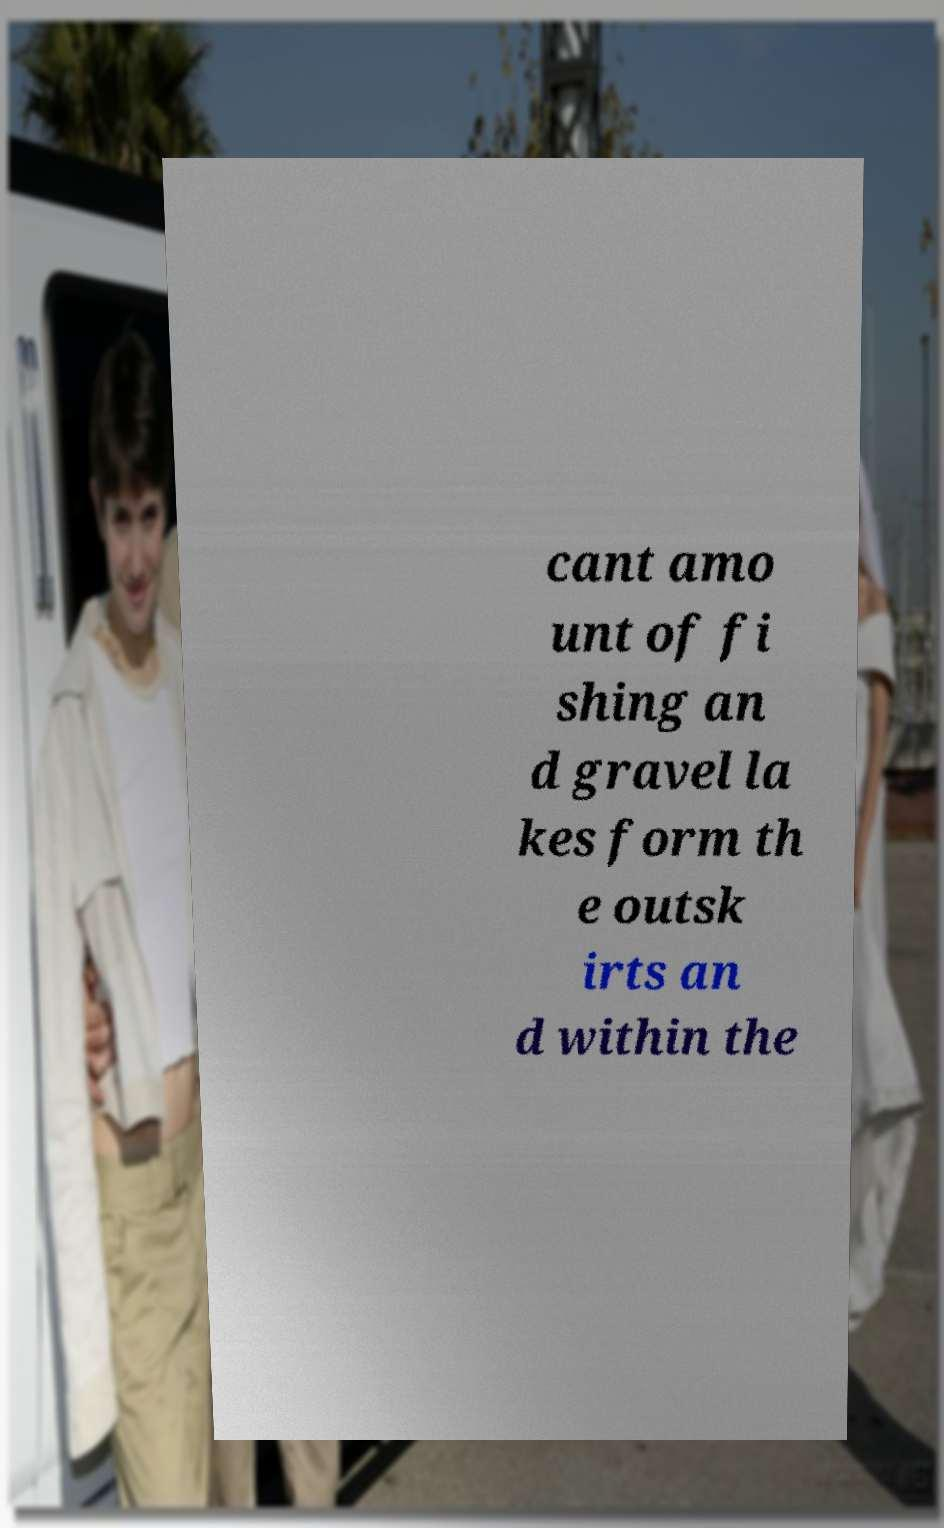I need the written content from this picture converted into text. Can you do that? cant amo unt of fi shing an d gravel la kes form th e outsk irts an d within the 